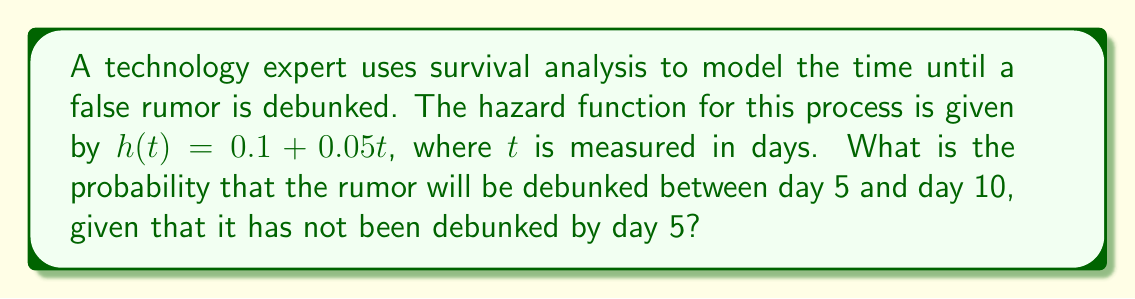Could you help me with this problem? To solve this problem, we'll follow these steps:

1) First, recall that the hazard function $h(t)$ is related to the survival function $S(t)$ by the equation:

   $$h(t) = -\frac{d}{dt}\ln S(t)$$

2) Integrating both sides:

   $$\int_0^t h(u) du = -\ln S(t) + C$$

3) Substituting the given hazard function:

   $$\int_0^t (0.1 + 0.05u) du = -\ln S(t) + C$$

4) Solving the integral:

   $$[0.1u + 0.025u^2]_0^t = -\ln S(t) + C$$
   $$0.1t + 0.025t^2 = -\ln S(t) + C$$

5) At $t=0$, $S(0) = 1$, so $C = 0$. Therefore:

   $$S(t) = \exp(-0.1t - 0.025t^2)$$

6) The probability of the rumor being debunked between day 5 and day 10, given it hasn't been debunked by day 5, is:

   $$P(5 < T \leq 10 | T > 5) = \frac{S(5) - S(10)}{S(5)}$$

7) Calculate $S(5)$ and $S(10)$:

   $$S(5) = \exp(-0.1(5) - 0.025(5^2)) = \exp(-1.125) \approx 0.3247$$
   $$S(10) = \exp(-0.1(10) - 0.025(10^2)) = \exp(-3.5) \approx 0.0302$$

8) Substitute these values into the probability formula:

   $$P(5 < T \leq 10 | T > 5) = \frac{0.3247 - 0.0302}{0.3247} \approx 0.9070$$
Answer: 0.9070 